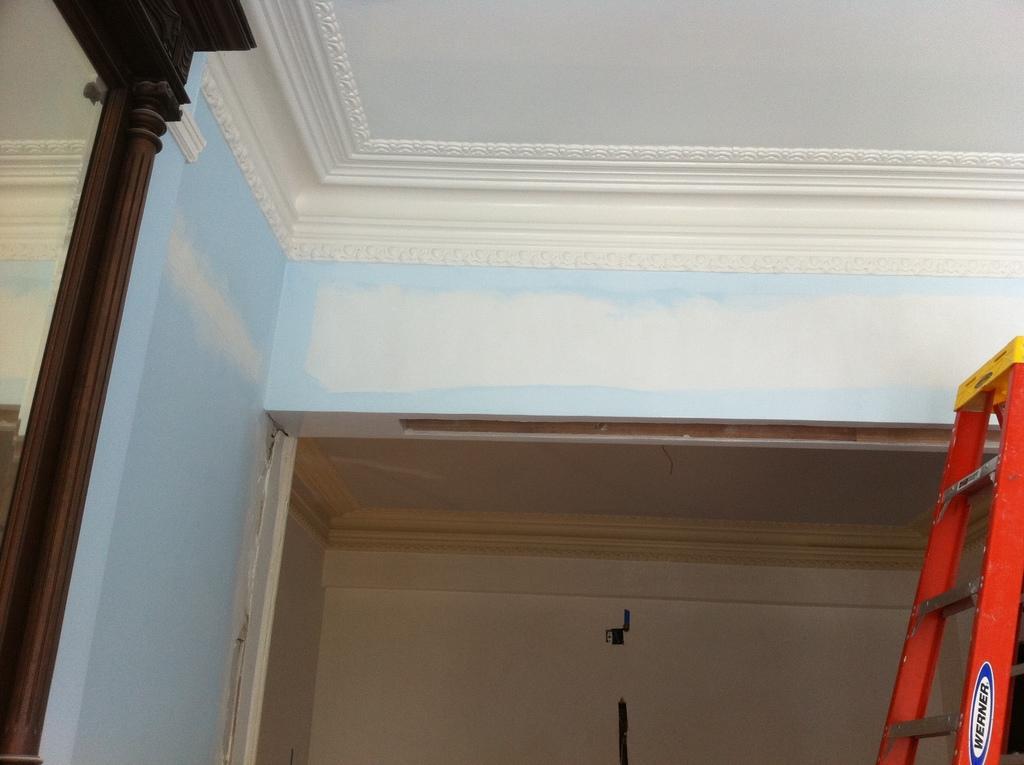Could you give a brief overview of what you see in this image? On the right there is a ladder. At the top there is a wall and ceiling. On the left there is a wooden object and wall. In the center of the picture it is well. 